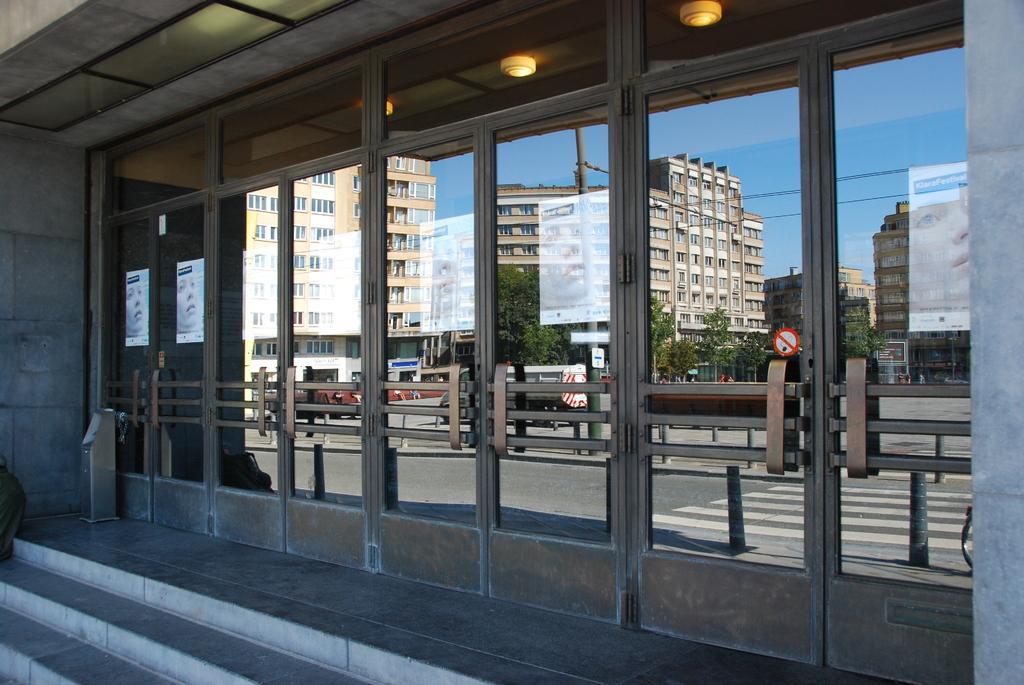Could you give a brief overview of what you see in this image? In this image, we can see buildings, lights, boards, vehicles on the road, banners, railings, stairs, trees and poles along with wires. 